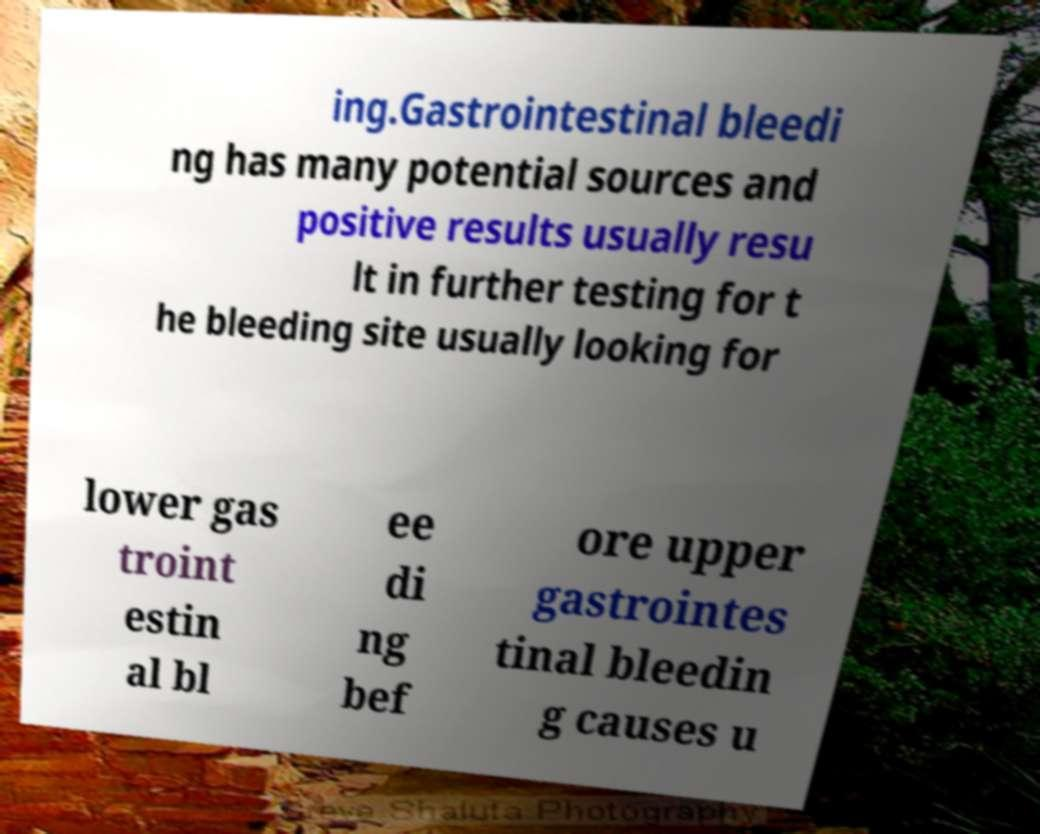Could you extract and type out the text from this image? ing.Gastrointestinal bleedi ng has many potential sources and positive results usually resu lt in further testing for t he bleeding site usually looking for lower gas troint estin al bl ee di ng bef ore upper gastrointes tinal bleedin g causes u 